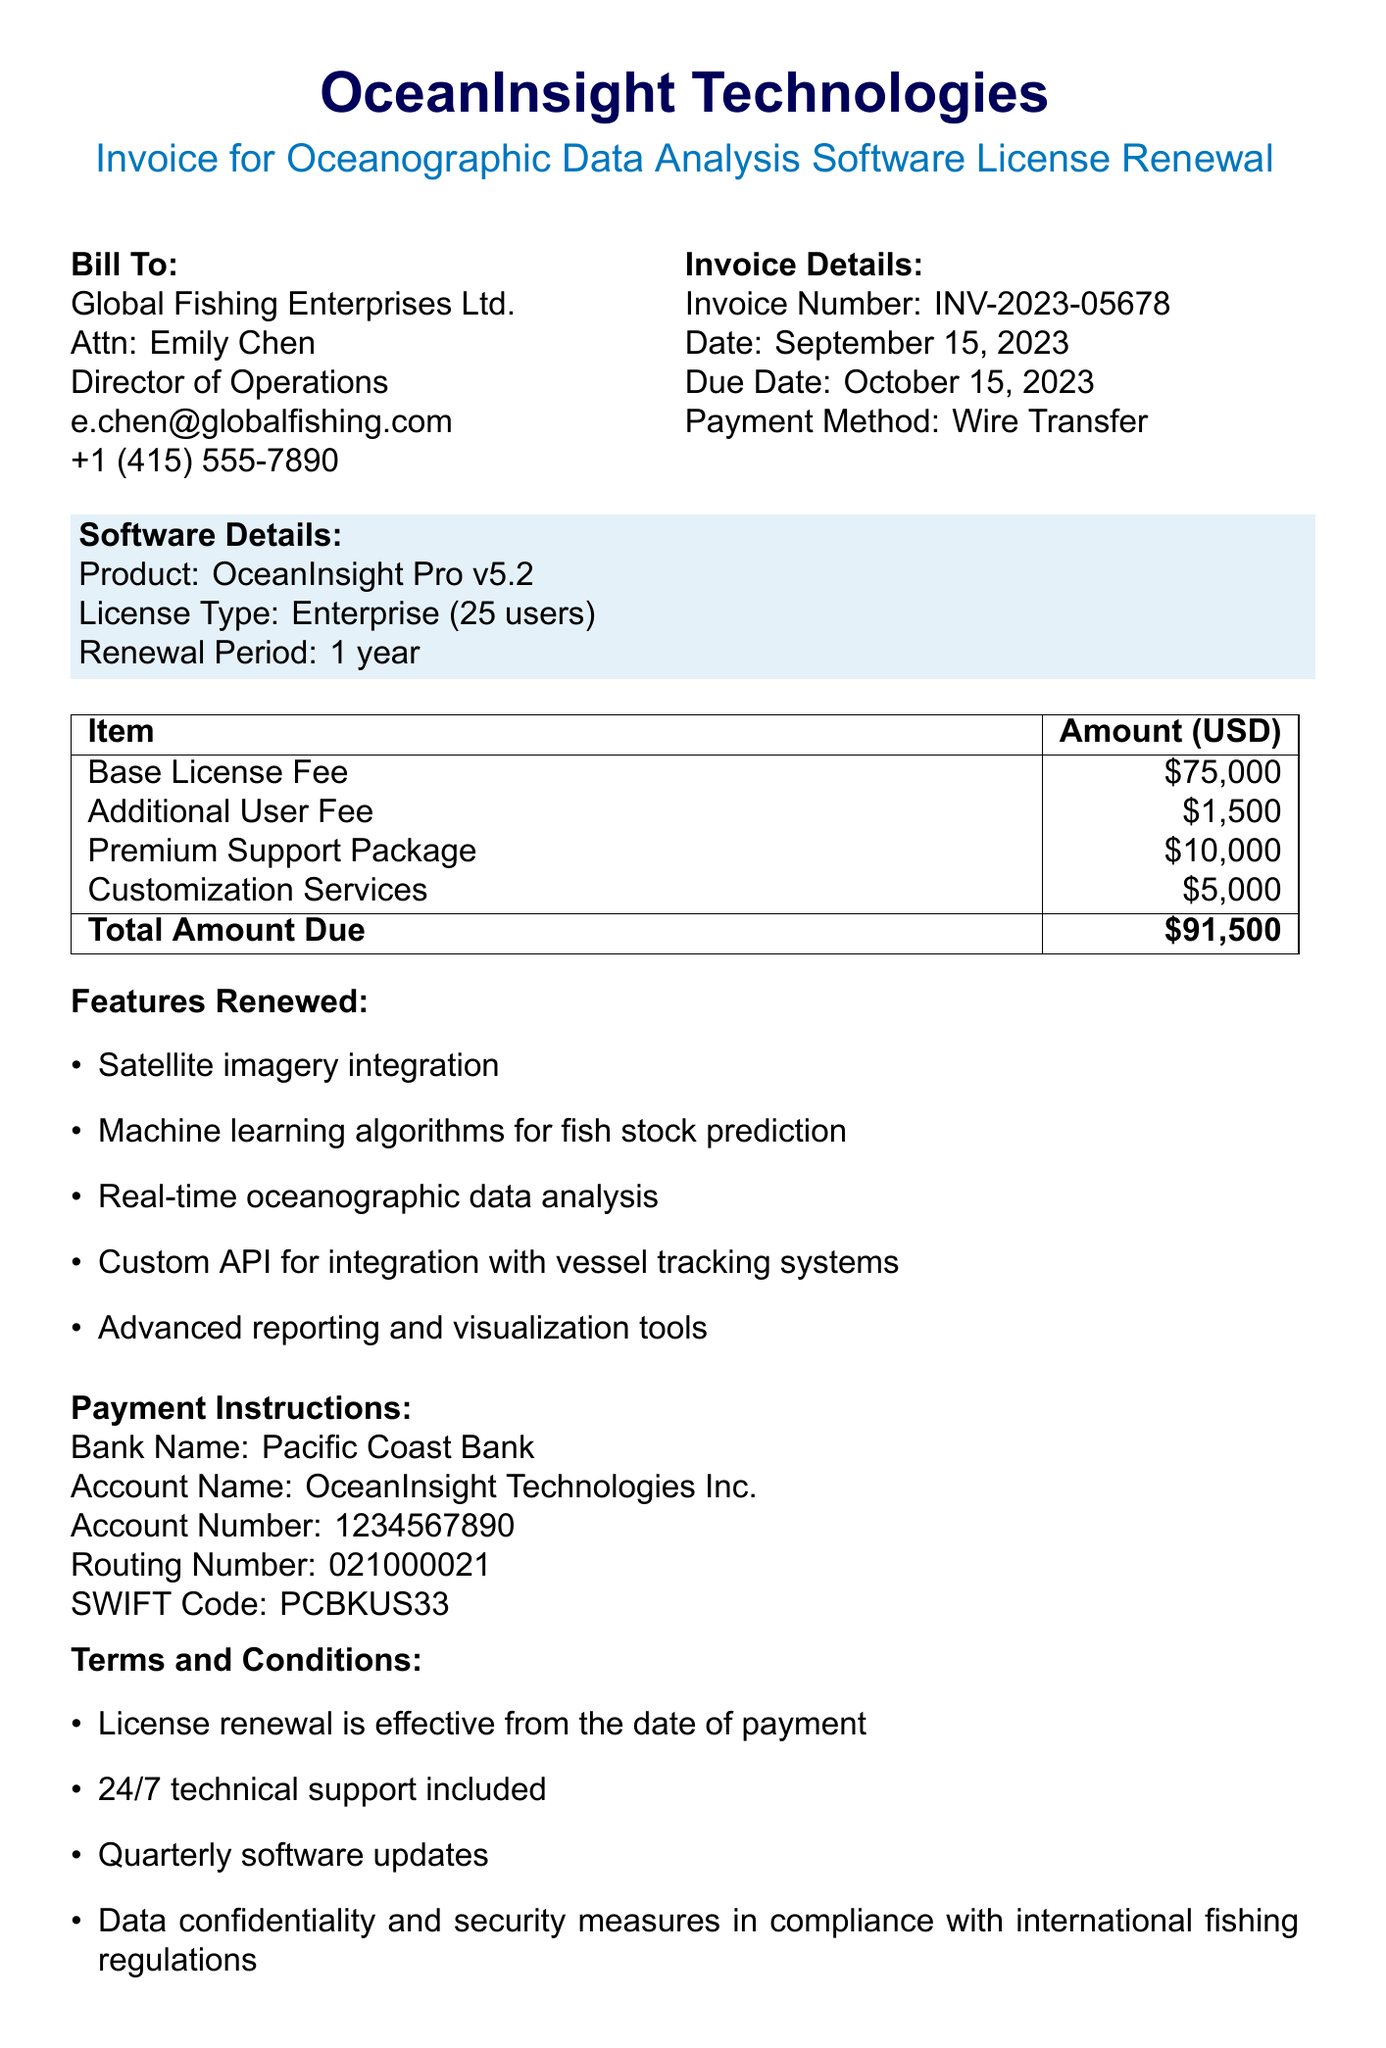What is the invoice number? The invoice number is explicitly mentioned in the document, which is a unique identifier for the transaction.
Answer: INV-2023-05678 Who is the contact at Global Fishing Enterprises Ltd.? The document states the contact person's name for the customer is critical for direct communication regarding the invoice.
Answer: Emily Chen What is the total amount due? The total amount due summarizes all costs associated with the software license renewal, clearly outlined in the pricing section of the document.
Answer: $91,500 When is the payment due? The due date is provided in the document to indicate by when the payment must be made.
Answer: October 15, 2023 What is the license type for OceanInsight Pro? The license type indicates the scale and nature of usage rights granted with the software, found in the software details section.
Answer: Enterprise Which payment method is mentioned in the document? The payment method indicates how the payment should be processed as per the transaction details.
Answer: Wire Transfer What features are included in the renewal? This question looks at the list of features renewed to understand the value of the software licensing.
Answer: Satellite imagery integration, Machine learning algorithms for fish stock prediction, Real-time oceanographic data analysis, Custom API for integration with vessel tracking systems, Advanced reporting and visualization tools What is the name of the vendor providing the software? Identifying the vendor helps in establishing who to contact for software-related inquiries or support.
Answer: OceanInsight Technologies What training session is scheduled, and when? The training session date is specified to inform the customer about the support provided for new features.
Answer: October 5, 2023 